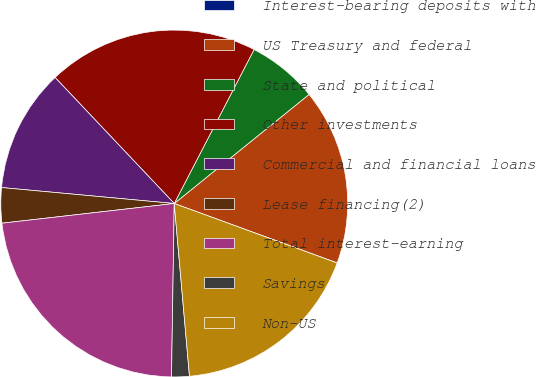Convert chart to OTSL. <chart><loc_0><loc_0><loc_500><loc_500><pie_chart><fcel>Interest-bearing deposits with<fcel>US Treasury and federal<fcel>State and political<fcel>Other investments<fcel>Commercial and financial loans<fcel>Lease financing(2)<fcel>Total interest-earning<fcel>Savings<fcel>Non-US<nl><fcel>0.01%<fcel>16.39%<fcel>6.56%<fcel>19.67%<fcel>11.48%<fcel>3.28%<fcel>22.94%<fcel>1.65%<fcel>18.03%<nl></chart> 